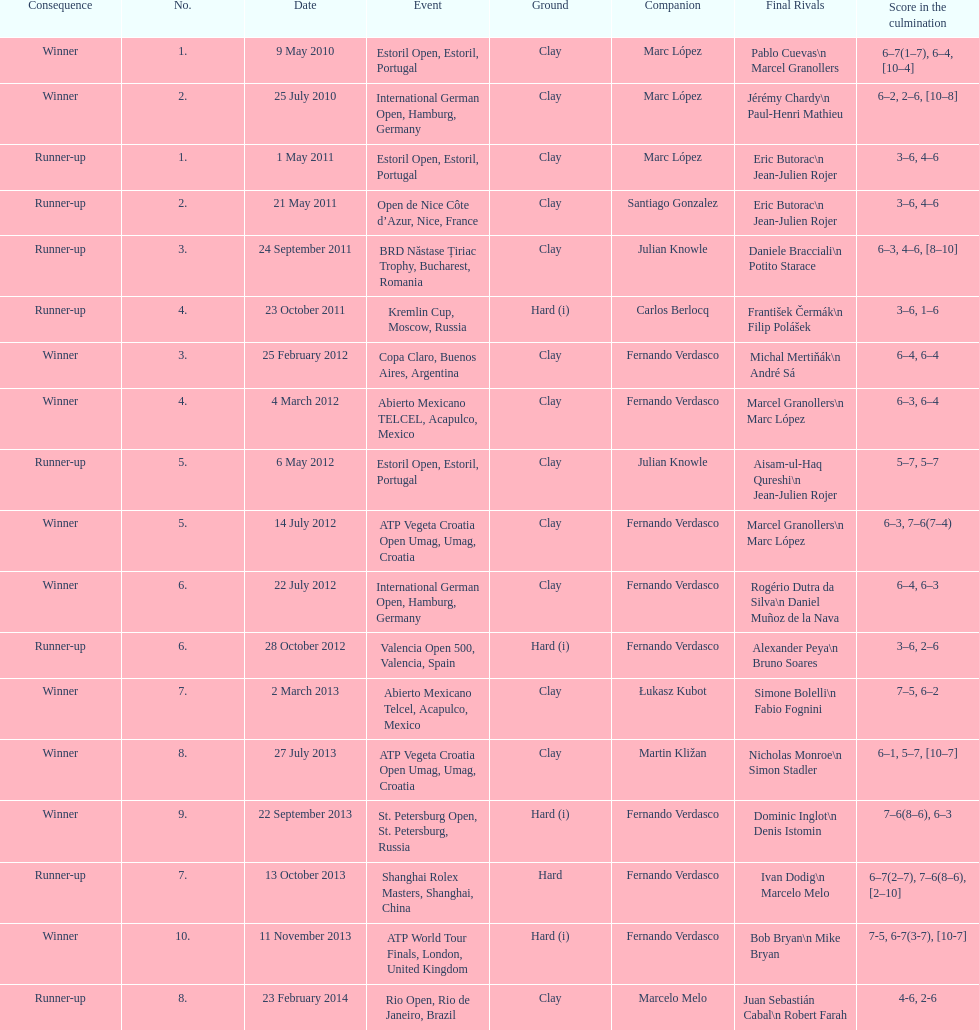How many winners are there? 10. 